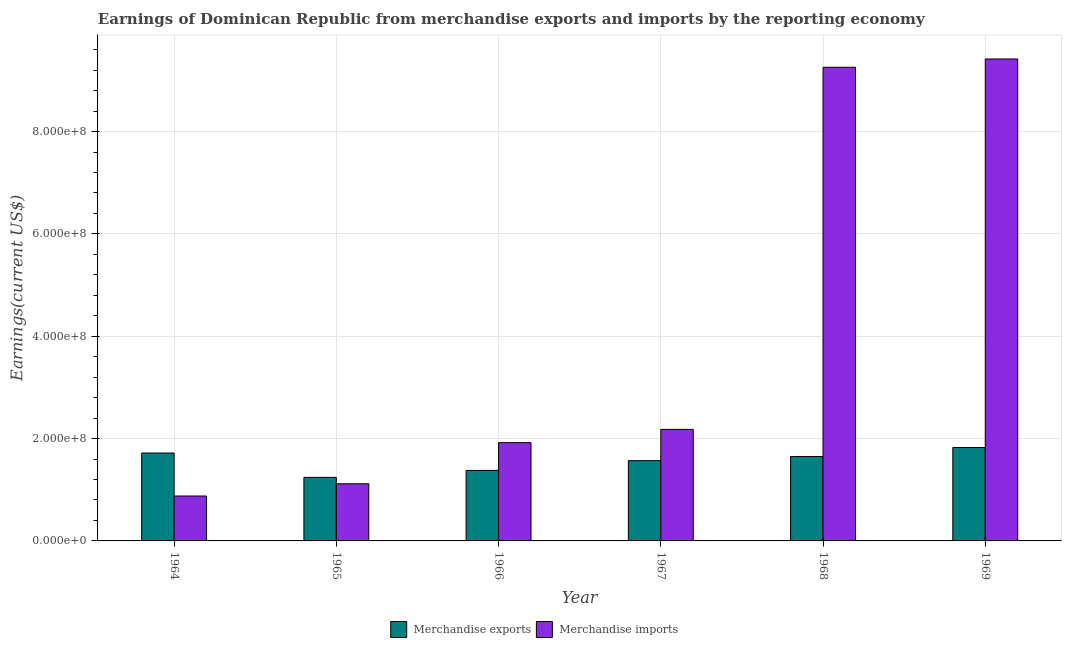How many different coloured bars are there?
Offer a very short reply. 2. Are the number of bars per tick equal to the number of legend labels?
Keep it short and to the point. Yes. How many bars are there on the 5th tick from the left?
Provide a short and direct response. 2. What is the label of the 2nd group of bars from the left?
Provide a succinct answer. 1965. What is the earnings from merchandise imports in 1964?
Your answer should be compact. 8.78e+07. Across all years, what is the maximum earnings from merchandise imports?
Offer a terse response. 9.42e+08. Across all years, what is the minimum earnings from merchandise imports?
Offer a very short reply. 8.78e+07. In which year was the earnings from merchandise exports maximum?
Give a very brief answer. 1969. In which year was the earnings from merchandise imports minimum?
Keep it short and to the point. 1964. What is the total earnings from merchandise imports in the graph?
Give a very brief answer. 2.48e+09. What is the difference between the earnings from merchandise imports in 1967 and that in 1969?
Keep it short and to the point. -7.24e+08. What is the difference between the earnings from merchandise exports in 1969 and the earnings from merchandise imports in 1968?
Keep it short and to the point. 1.77e+07. What is the average earnings from merchandise exports per year?
Your answer should be very brief. 1.56e+08. In the year 1968, what is the difference between the earnings from merchandise exports and earnings from merchandise imports?
Offer a very short reply. 0. What is the ratio of the earnings from merchandise exports in 1964 to that in 1966?
Give a very brief answer. 1.25. Is the earnings from merchandise imports in 1965 less than that in 1969?
Keep it short and to the point. Yes. What is the difference between the highest and the second highest earnings from merchandise imports?
Provide a succinct answer. 1.62e+07. What is the difference between the highest and the lowest earnings from merchandise exports?
Give a very brief answer. 5.84e+07. How many bars are there?
Offer a very short reply. 12. How many years are there in the graph?
Your response must be concise. 6. Does the graph contain grids?
Your response must be concise. Yes. How many legend labels are there?
Make the answer very short. 2. What is the title of the graph?
Your answer should be compact. Earnings of Dominican Republic from merchandise exports and imports by the reporting economy. What is the label or title of the X-axis?
Provide a short and direct response. Year. What is the label or title of the Y-axis?
Your response must be concise. Earnings(current US$). What is the Earnings(current US$) in Merchandise exports in 1964?
Make the answer very short. 1.72e+08. What is the Earnings(current US$) of Merchandise imports in 1964?
Provide a short and direct response. 8.78e+07. What is the Earnings(current US$) of Merchandise exports in 1965?
Your response must be concise. 1.24e+08. What is the Earnings(current US$) of Merchandise imports in 1965?
Provide a succinct answer. 1.12e+08. What is the Earnings(current US$) of Merchandise exports in 1966?
Your answer should be very brief. 1.38e+08. What is the Earnings(current US$) in Merchandise imports in 1966?
Provide a short and direct response. 1.92e+08. What is the Earnings(current US$) in Merchandise exports in 1967?
Your response must be concise. 1.57e+08. What is the Earnings(current US$) in Merchandise imports in 1967?
Your response must be concise. 2.18e+08. What is the Earnings(current US$) of Merchandise exports in 1968?
Your answer should be compact. 1.65e+08. What is the Earnings(current US$) in Merchandise imports in 1968?
Make the answer very short. 9.26e+08. What is the Earnings(current US$) of Merchandise exports in 1969?
Provide a short and direct response. 1.83e+08. What is the Earnings(current US$) of Merchandise imports in 1969?
Your answer should be compact. 9.42e+08. Across all years, what is the maximum Earnings(current US$) in Merchandise exports?
Offer a terse response. 1.83e+08. Across all years, what is the maximum Earnings(current US$) in Merchandise imports?
Give a very brief answer. 9.42e+08. Across all years, what is the minimum Earnings(current US$) in Merchandise exports?
Ensure brevity in your answer.  1.24e+08. Across all years, what is the minimum Earnings(current US$) in Merchandise imports?
Make the answer very short. 8.78e+07. What is the total Earnings(current US$) of Merchandise exports in the graph?
Your answer should be compact. 9.38e+08. What is the total Earnings(current US$) in Merchandise imports in the graph?
Your answer should be very brief. 2.48e+09. What is the difference between the Earnings(current US$) in Merchandise exports in 1964 and that in 1965?
Provide a short and direct response. 4.76e+07. What is the difference between the Earnings(current US$) of Merchandise imports in 1964 and that in 1965?
Give a very brief answer. -2.39e+07. What is the difference between the Earnings(current US$) in Merchandise exports in 1964 and that in 1966?
Give a very brief answer. 3.40e+07. What is the difference between the Earnings(current US$) in Merchandise imports in 1964 and that in 1966?
Provide a short and direct response. -1.04e+08. What is the difference between the Earnings(current US$) in Merchandise exports in 1964 and that in 1967?
Your response must be concise. 1.49e+07. What is the difference between the Earnings(current US$) of Merchandise imports in 1964 and that in 1967?
Offer a terse response. -1.30e+08. What is the difference between the Earnings(current US$) of Merchandise exports in 1964 and that in 1968?
Offer a terse response. 6.85e+06. What is the difference between the Earnings(current US$) of Merchandise imports in 1964 and that in 1968?
Your answer should be compact. -8.38e+08. What is the difference between the Earnings(current US$) in Merchandise exports in 1964 and that in 1969?
Your answer should be compact. -1.08e+07. What is the difference between the Earnings(current US$) of Merchandise imports in 1964 and that in 1969?
Your response must be concise. -8.54e+08. What is the difference between the Earnings(current US$) in Merchandise exports in 1965 and that in 1966?
Provide a short and direct response. -1.35e+07. What is the difference between the Earnings(current US$) in Merchandise imports in 1965 and that in 1966?
Offer a terse response. -8.04e+07. What is the difference between the Earnings(current US$) in Merchandise exports in 1965 and that in 1967?
Keep it short and to the point. -3.27e+07. What is the difference between the Earnings(current US$) in Merchandise imports in 1965 and that in 1967?
Give a very brief answer. -1.06e+08. What is the difference between the Earnings(current US$) of Merchandise exports in 1965 and that in 1968?
Keep it short and to the point. -4.07e+07. What is the difference between the Earnings(current US$) of Merchandise imports in 1965 and that in 1968?
Give a very brief answer. -8.14e+08. What is the difference between the Earnings(current US$) in Merchandise exports in 1965 and that in 1969?
Your answer should be compact. -5.84e+07. What is the difference between the Earnings(current US$) of Merchandise imports in 1965 and that in 1969?
Your answer should be very brief. -8.30e+08. What is the difference between the Earnings(current US$) in Merchandise exports in 1966 and that in 1967?
Keep it short and to the point. -1.91e+07. What is the difference between the Earnings(current US$) of Merchandise imports in 1966 and that in 1967?
Your answer should be compact. -2.59e+07. What is the difference between the Earnings(current US$) of Merchandise exports in 1966 and that in 1968?
Provide a succinct answer. -2.72e+07. What is the difference between the Earnings(current US$) in Merchandise imports in 1966 and that in 1968?
Offer a terse response. -7.34e+08. What is the difference between the Earnings(current US$) of Merchandise exports in 1966 and that in 1969?
Your response must be concise. -4.48e+07. What is the difference between the Earnings(current US$) of Merchandise imports in 1966 and that in 1969?
Offer a terse response. -7.50e+08. What is the difference between the Earnings(current US$) in Merchandise exports in 1967 and that in 1968?
Offer a terse response. -8.04e+06. What is the difference between the Earnings(current US$) in Merchandise imports in 1967 and that in 1968?
Ensure brevity in your answer.  -7.08e+08. What is the difference between the Earnings(current US$) in Merchandise exports in 1967 and that in 1969?
Your answer should be very brief. -2.57e+07. What is the difference between the Earnings(current US$) in Merchandise imports in 1967 and that in 1969?
Give a very brief answer. -7.24e+08. What is the difference between the Earnings(current US$) of Merchandise exports in 1968 and that in 1969?
Provide a succinct answer. -1.77e+07. What is the difference between the Earnings(current US$) of Merchandise imports in 1968 and that in 1969?
Offer a terse response. -1.62e+07. What is the difference between the Earnings(current US$) of Merchandise exports in 1964 and the Earnings(current US$) of Merchandise imports in 1965?
Give a very brief answer. 6.01e+07. What is the difference between the Earnings(current US$) in Merchandise exports in 1964 and the Earnings(current US$) in Merchandise imports in 1966?
Keep it short and to the point. -2.03e+07. What is the difference between the Earnings(current US$) in Merchandise exports in 1964 and the Earnings(current US$) in Merchandise imports in 1967?
Provide a succinct answer. -4.62e+07. What is the difference between the Earnings(current US$) in Merchandise exports in 1964 and the Earnings(current US$) in Merchandise imports in 1968?
Offer a terse response. -7.54e+08. What is the difference between the Earnings(current US$) of Merchandise exports in 1964 and the Earnings(current US$) of Merchandise imports in 1969?
Your answer should be very brief. -7.70e+08. What is the difference between the Earnings(current US$) in Merchandise exports in 1965 and the Earnings(current US$) in Merchandise imports in 1966?
Make the answer very short. -6.78e+07. What is the difference between the Earnings(current US$) of Merchandise exports in 1965 and the Earnings(current US$) of Merchandise imports in 1967?
Offer a terse response. -9.37e+07. What is the difference between the Earnings(current US$) of Merchandise exports in 1965 and the Earnings(current US$) of Merchandise imports in 1968?
Your answer should be compact. -8.02e+08. What is the difference between the Earnings(current US$) in Merchandise exports in 1965 and the Earnings(current US$) in Merchandise imports in 1969?
Your response must be concise. -8.18e+08. What is the difference between the Earnings(current US$) of Merchandise exports in 1966 and the Earnings(current US$) of Merchandise imports in 1967?
Make the answer very short. -8.02e+07. What is the difference between the Earnings(current US$) of Merchandise exports in 1966 and the Earnings(current US$) of Merchandise imports in 1968?
Make the answer very short. -7.88e+08. What is the difference between the Earnings(current US$) of Merchandise exports in 1966 and the Earnings(current US$) of Merchandise imports in 1969?
Ensure brevity in your answer.  -8.04e+08. What is the difference between the Earnings(current US$) of Merchandise exports in 1967 and the Earnings(current US$) of Merchandise imports in 1968?
Make the answer very short. -7.69e+08. What is the difference between the Earnings(current US$) of Merchandise exports in 1967 and the Earnings(current US$) of Merchandise imports in 1969?
Offer a very short reply. -7.85e+08. What is the difference between the Earnings(current US$) in Merchandise exports in 1968 and the Earnings(current US$) in Merchandise imports in 1969?
Your response must be concise. -7.77e+08. What is the average Earnings(current US$) of Merchandise exports per year?
Your answer should be compact. 1.56e+08. What is the average Earnings(current US$) of Merchandise imports per year?
Your response must be concise. 4.13e+08. In the year 1964, what is the difference between the Earnings(current US$) in Merchandise exports and Earnings(current US$) in Merchandise imports?
Provide a succinct answer. 8.40e+07. In the year 1965, what is the difference between the Earnings(current US$) of Merchandise exports and Earnings(current US$) of Merchandise imports?
Give a very brief answer. 1.25e+07. In the year 1966, what is the difference between the Earnings(current US$) of Merchandise exports and Earnings(current US$) of Merchandise imports?
Your answer should be compact. -5.43e+07. In the year 1967, what is the difference between the Earnings(current US$) of Merchandise exports and Earnings(current US$) of Merchandise imports?
Offer a very short reply. -6.10e+07. In the year 1968, what is the difference between the Earnings(current US$) of Merchandise exports and Earnings(current US$) of Merchandise imports?
Provide a short and direct response. -7.61e+08. In the year 1969, what is the difference between the Earnings(current US$) of Merchandise exports and Earnings(current US$) of Merchandise imports?
Offer a very short reply. -7.59e+08. What is the ratio of the Earnings(current US$) of Merchandise exports in 1964 to that in 1965?
Your answer should be compact. 1.38. What is the ratio of the Earnings(current US$) in Merchandise imports in 1964 to that in 1965?
Your answer should be very brief. 0.79. What is the ratio of the Earnings(current US$) in Merchandise exports in 1964 to that in 1966?
Give a very brief answer. 1.25. What is the ratio of the Earnings(current US$) in Merchandise imports in 1964 to that in 1966?
Give a very brief answer. 0.46. What is the ratio of the Earnings(current US$) of Merchandise exports in 1964 to that in 1967?
Make the answer very short. 1.09. What is the ratio of the Earnings(current US$) in Merchandise imports in 1964 to that in 1967?
Provide a short and direct response. 0.4. What is the ratio of the Earnings(current US$) of Merchandise exports in 1964 to that in 1968?
Provide a succinct answer. 1.04. What is the ratio of the Earnings(current US$) of Merchandise imports in 1964 to that in 1968?
Keep it short and to the point. 0.09. What is the ratio of the Earnings(current US$) of Merchandise exports in 1964 to that in 1969?
Make the answer very short. 0.94. What is the ratio of the Earnings(current US$) in Merchandise imports in 1964 to that in 1969?
Make the answer very short. 0.09. What is the ratio of the Earnings(current US$) in Merchandise exports in 1965 to that in 1966?
Ensure brevity in your answer.  0.9. What is the ratio of the Earnings(current US$) in Merchandise imports in 1965 to that in 1966?
Give a very brief answer. 0.58. What is the ratio of the Earnings(current US$) of Merchandise exports in 1965 to that in 1967?
Your answer should be very brief. 0.79. What is the ratio of the Earnings(current US$) of Merchandise imports in 1965 to that in 1967?
Offer a very short reply. 0.51. What is the ratio of the Earnings(current US$) in Merchandise exports in 1965 to that in 1968?
Your response must be concise. 0.75. What is the ratio of the Earnings(current US$) in Merchandise imports in 1965 to that in 1968?
Offer a very short reply. 0.12. What is the ratio of the Earnings(current US$) of Merchandise exports in 1965 to that in 1969?
Provide a succinct answer. 0.68. What is the ratio of the Earnings(current US$) in Merchandise imports in 1965 to that in 1969?
Your answer should be compact. 0.12. What is the ratio of the Earnings(current US$) in Merchandise exports in 1966 to that in 1967?
Provide a succinct answer. 0.88. What is the ratio of the Earnings(current US$) in Merchandise imports in 1966 to that in 1967?
Provide a short and direct response. 0.88. What is the ratio of the Earnings(current US$) of Merchandise exports in 1966 to that in 1968?
Ensure brevity in your answer.  0.84. What is the ratio of the Earnings(current US$) in Merchandise imports in 1966 to that in 1968?
Give a very brief answer. 0.21. What is the ratio of the Earnings(current US$) in Merchandise exports in 1966 to that in 1969?
Your answer should be very brief. 0.75. What is the ratio of the Earnings(current US$) of Merchandise imports in 1966 to that in 1969?
Make the answer very short. 0.2. What is the ratio of the Earnings(current US$) in Merchandise exports in 1967 to that in 1968?
Keep it short and to the point. 0.95. What is the ratio of the Earnings(current US$) of Merchandise imports in 1967 to that in 1968?
Keep it short and to the point. 0.24. What is the ratio of the Earnings(current US$) of Merchandise exports in 1967 to that in 1969?
Offer a very short reply. 0.86. What is the ratio of the Earnings(current US$) of Merchandise imports in 1967 to that in 1969?
Keep it short and to the point. 0.23. What is the ratio of the Earnings(current US$) in Merchandise exports in 1968 to that in 1969?
Your response must be concise. 0.9. What is the ratio of the Earnings(current US$) in Merchandise imports in 1968 to that in 1969?
Your answer should be very brief. 0.98. What is the difference between the highest and the second highest Earnings(current US$) of Merchandise exports?
Offer a very short reply. 1.08e+07. What is the difference between the highest and the second highest Earnings(current US$) in Merchandise imports?
Your answer should be very brief. 1.62e+07. What is the difference between the highest and the lowest Earnings(current US$) in Merchandise exports?
Make the answer very short. 5.84e+07. What is the difference between the highest and the lowest Earnings(current US$) of Merchandise imports?
Ensure brevity in your answer.  8.54e+08. 